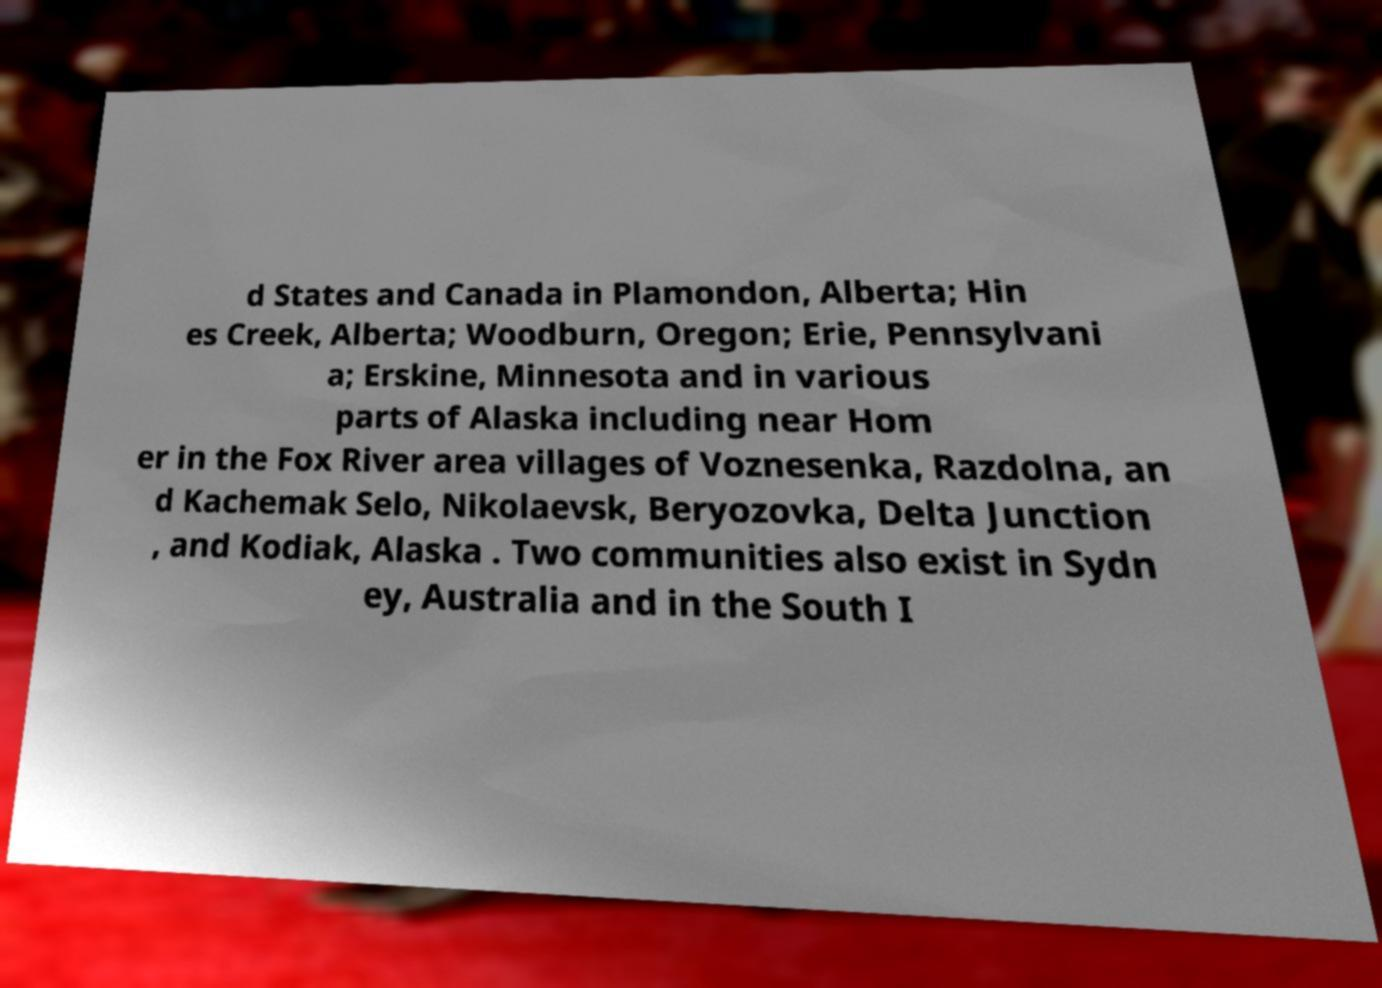Could you assist in decoding the text presented in this image and type it out clearly? d States and Canada in Plamondon, Alberta; Hin es Creek, Alberta; Woodburn, Oregon; Erie, Pennsylvani a; Erskine, Minnesota and in various parts of Alaska including near Hom er in the Fox River area villages of Voznesenka, Razdolna, an d Kachemak Selo, Nikolaevsk, Beryozovka, Delta Junction , and Kodiak, Alaska . Two communities also exist in Sydn ey, Australia and in the South I 